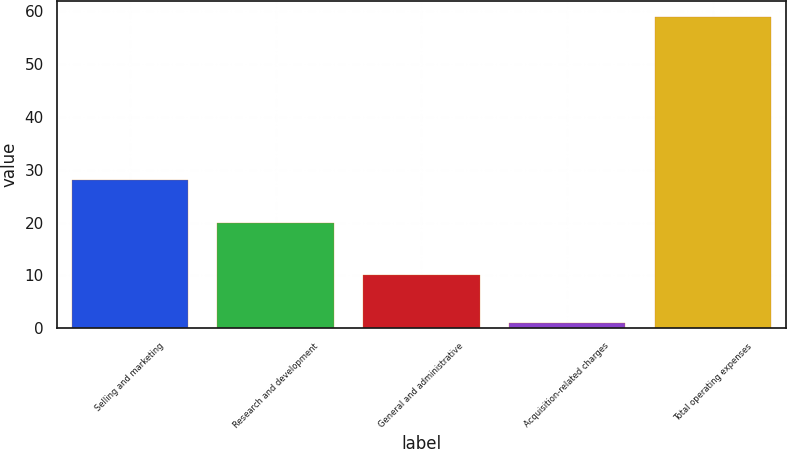<chart> <loc_0><loc_0><loc_500><loc_500><bar_chart><fcel>Selling and marketing<fcel>Research and development<fcel>General and administrative<fcel>Acquisition-related charges<fcel>Total operating expenses<nl><fcel>28<fcel>20<fcel>10<fcel>1<fcel>59<nl></chart> 